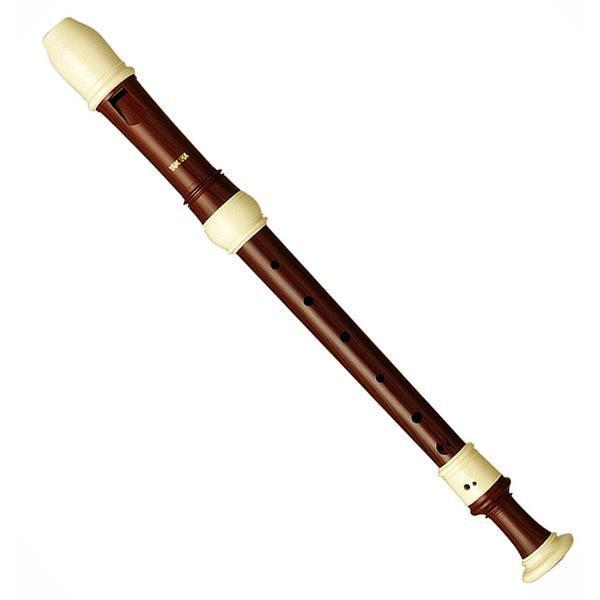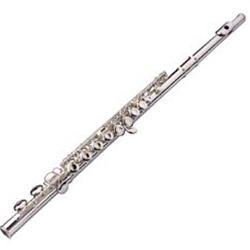The first image is the image on the left, the second image is the image on the right. Considering the images on both sides, is "There are two curved head flutes." valid? Answer yes or no. No. 